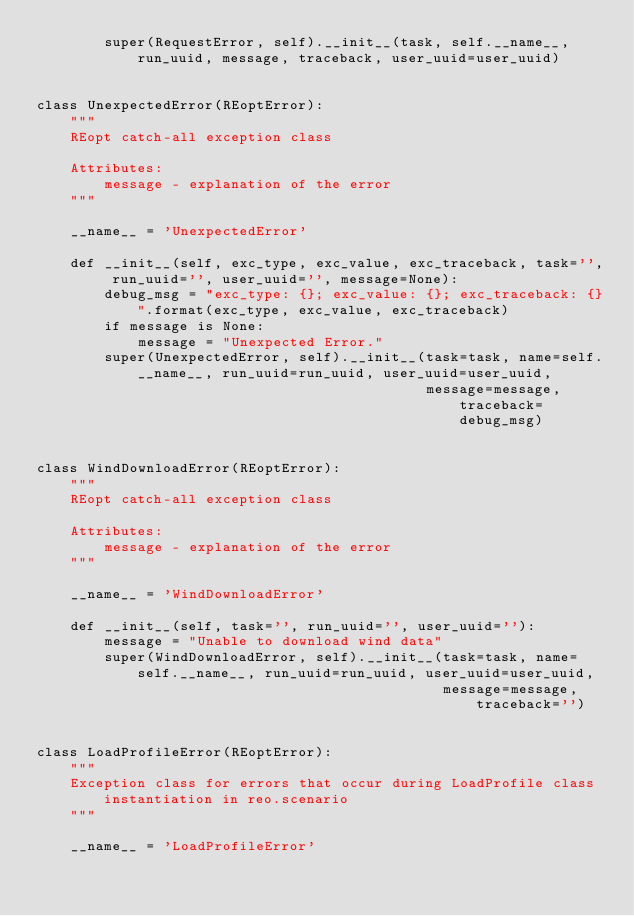Convert code to text. <code><loc_0><loc_0><loc_500><loc_500><_Python_>        super(RequestError, self).__init__(task, self.__name__, run_uuid, message, traceback, user_uuid=user_uuid)


class UnexpectedError(REoptError):
    """
    REopt catch-all exception class

    Attributes:
        message - explanation of the error
    """

    __name__ = 'UnexpectedError'

    def __init__(self, exc_type, exc_value, exc_traceback, task='', run_uuid='', user_uuid='', message=None):
        debug_msg = "exc_type: {}; exc_value: {}; exc_traceback: {}".format(exc_type, exc_value, exc_traceback)
        if message is None:
            message = "Unexpected Error."
        super(UnexpectedError, self).__init__(task=task, name=self.__name__, run_uuid=run_uuid, user_uuid=user_uuid,
                                              message=message, traceback=debug_msg)


class WindDownloadError(REoptError):
    """
    REopt catch-all exception class

    Attributes:
        message - explanation of the error
    """

    __name__ = 'WindDownloadError'

    def __init__(self, task='', run_uuid='', user_uuid=''):
        message = "Unable to download wind data"
        super(WindDownloadError, self).__init__(task=task, name=self.__name__, run_uuid=run_uuid, user_uuid=user_uuid,
                                                message=message, traceback='')


class LoadProfileError(REoptError):
    """
    Exception class for errors that occur during LoadProfile class instantiation in reo.scenario
    """

    __name__ = 'LoadProfileError'
</code> 